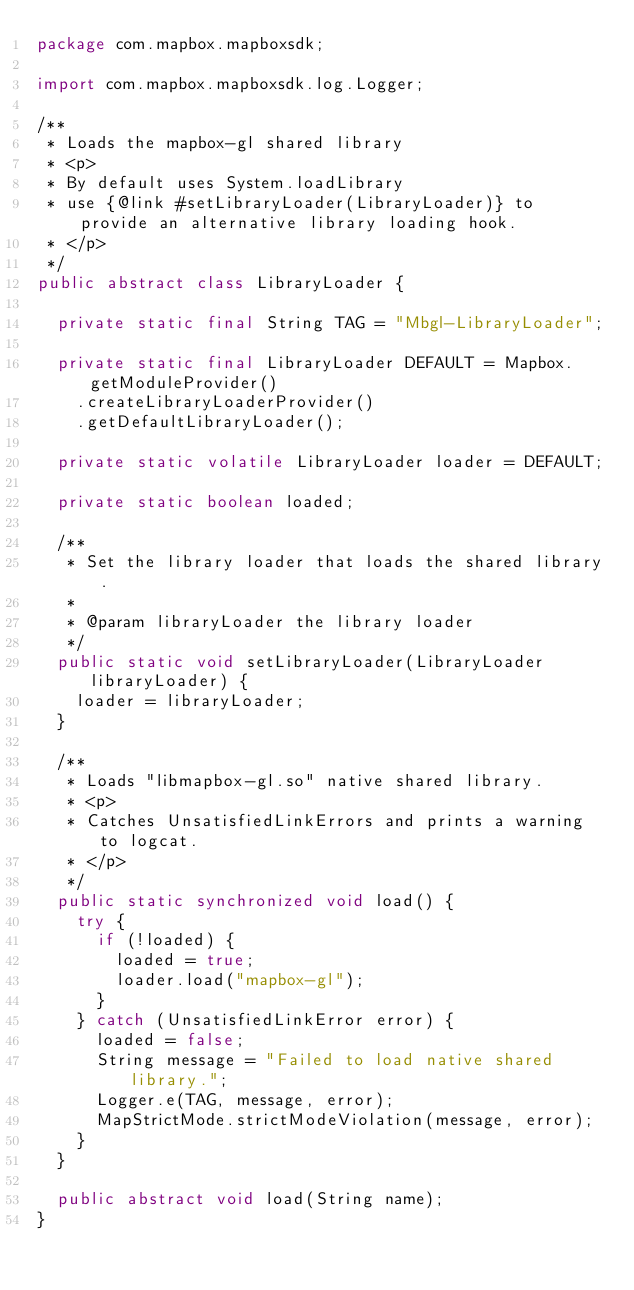<code> <loc_0><loc_0><loc_500><loc_500><_Java_>package com.mapbox.mapboxsdk;

import com.mapbox.mapboxsdk.log.Logger;

/**
 * Loads the mapbox-gl shared library
 * <p>
 * By default uses System.loadLibrary
 * use {@link #setLibraryLoader(LibraryLoader)} to provide an alternative library loading hook.
 * </p>
 */
public abstract class LibraryLoader {

  private static final String TAG = "Mbgl-LibraryLoader";

  private static final LibraryLoader DEFAULT = Mapbox.getModuleProvider()
    .createLibraryLoaderProvider()
    .getDefaultLibraryLoader();

  private static volatile LibraryLoader loader = DEFAULT;

  private static boolean loaded;

  /**
   * Set the library loader that loads the shared library.
   *
   * @param libraryLoader the library loader
   */
  public static void setLibraryLoader(LibraryLoader libraryLoader) {
    loader = libraryLoader;
  }

  /**
   * Loads "libmapbox-gl.so" native shared library.
   * <p>
   * Catches UnsatisfiedLinkErrors and prints a warning to logcat.
   * </p>
   */
  public static synchronized void load() {
    try {
      if (!loaded) {
        loaded = true;
        loader.load("mapbox-gl");
      }
    } catch (UnsatisfiedLinkError error) {
      loaded = false;
      String message = "Failed to load native shared library.";
      Logger.e(TAG, message, error);
      MapStrictMode.strictModeViolation(message, error);
    }
  }

  public abstract void load(String name);
}

</code> 